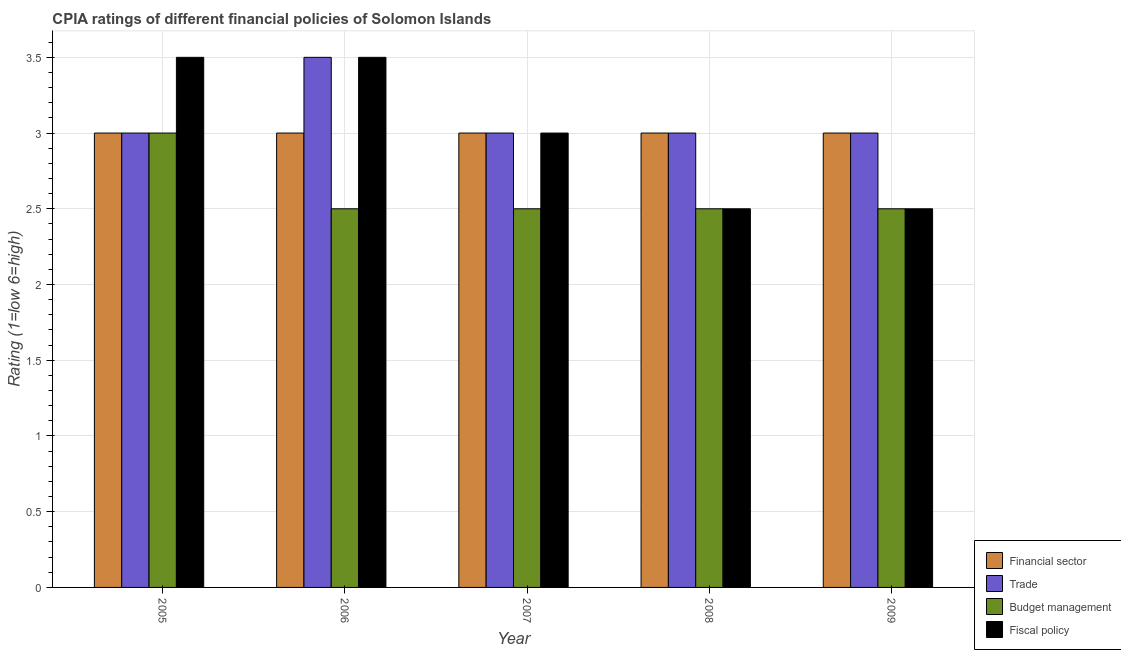How many different coloured bars are there?
Offer a very short reply. 4. Are the number of bars on each tick of the X-axis equal?
Make the answer very short. Yes. Across all years, what is the maximum cpia rating of fiscal policy?
Your response must be concise. 3.5. In which year was the cpia rating of financial sector maximum?
Your response must be concise. 2005. In which year was the cpia rating of financial sector minimum?
Your answer should be very brief. 2005. What is the difference between the cpia rating of trade in 2005 and the cpia rating of financial sector in 2009?
Provide a succinct answer. 0. What is the average cpia rating of budget management per year?
Your response must be concise. 2.6. What is the ratio of the cpia rating of budget management in 2005 to that in 2006?
Offer a very short reply. 1.2. What is the difference between the highest and the lowest cpia rating of trade?
Provide a short and direct response. 0.5. Is it the case that in every year, the sum of the cpia rating of fiscal policy and cpia rating of financial sector is greater than the sum of cpia rating of budget management and cpia rating of trade?
Ensure brevity in your answer.  No. What does the 1st bar from the left in 2007 represents?
Keep it short and to the point. Financial sector. What does the 4th bar from the right in 2008 represents?
Ensure brevity in your answer.  Financial sector. How many bars are there?
Your response must be concise. 20. What is the difference between two consecutive major ticks on the Y-axis?
Offer a very short reply. 0.5. Where does the legend appear in the graph?
Make the answer very short. Bottom right. What is the title of the graph?
Provide a short and direct response. CPIA ratings of different financial policies of Solomon Islands. Does "Norway" appear as one of the legend labels in the graph?
Your answer should be very brief. No. What is the label or title of the X-axis?
Ensure brevity in your answer.  Year. What is the Rating (1=low 6=high) in Trade in 2005?
Give a very brief answer. 3. What is the Rating (1=low 6=high) in Budget management in 2005?
Make the answer very short. 3. What is the Rating (1=low 6=high) in Fiscal policy in 2005?
Make the answer very short. 3.5. What is the Rating (1=low 6=high) in Trade in 2006?
Provide a short and direct response. 3.5. What is the Rating (1=low 6=high) of Financial sector in 2007?
Offer a very short reply. 3. What is the Rating (1=low 6=high) in Trade in 2007?
Your answer should be compact. 3. What is the Rating (1=low 6=high) in Budget management in 2007?
Provide a short and direct response. 2.5. What is the Rating (1=low 6=high) of Fiscal policy in 2007?
Keep it short and to the point. 3. What is the Rating (1=low 6=high) in Trade in 2008?
Make the answer very short. 3. What is the Rating (1=low 6=high) in Budget management in 2008?
Offer a terse response. 2.5. What is the Rating (1=low 6=high) of Financial sector in 2009?
Your response must be concise. 3. What is the Rating (1=low 6=high) of Trade in 2009?
Give a very brief answer. 3. What is the Rating (1=low 6=high) in Fiscal policy in 2009?
Keep it short and to the point. 2.5. Across all years, what is the minimum Rating (1=low 6=high) in Financial sector?
Give a very brief answer. 3. Across all years, what is the minimum Rating (1=low 6=high) of Trade?
Keep it short and to the point. 3. Across all years, what is the minimum Rating (1=low 6=high) of Fiscal policy?
Give a very brief answer. 2.5. What is the total Rating (1=low 6=high) of Financial sector in the graph?
Make the answer very short. 15. What is the total Rating (1=low 6=high) in Budget management in the graph?
Your answer should be compact. 13. What is the difference between the Rating (1=low 6=high) of Financial sector in 2005 and that in 2006?
Offer a terse response. 0. What is the difference between the Rating (1=low 6=high) of Budget management in 2005 and that in 2006?
Provide a short and direct response. 0.5. What is the difference between the Rating (1=low 6=high) in Fiscal policy in 2005 and that in 2006?
Ensure brevity in your answer.  0. What is the difference between the Rating (1=low 6=high) in Financial sector in 2005 and that in 2007?
Keep it short and to the point. 0. What is the difference between the Rating (1=low 6=high) in Fiscal policy in 2005 and that in 2007?
Your response must be concise. 0.5. What is the difference between the Rating (1=low 6=high) in Financial sector in 2005 and that in 2009?
Your response must be concise. 0. What is the difference between the Rating (1=low 6=high) in Budget management in 2005 and that in 2009?
Give a very brief answer. 0.5. What is the difference between the Rating (1=low 6=high) of Fiscal policy in 2005 and that in 2009?
Make the answer very short. 1. What is the difference between the Rating (1=low 6=high) of Financial sector in 2006 and that in 2007?
Your answer should be compact. 0. What is the difference between the Rating (1=low 6=high) of Trade in 2006 and that in 2007?
Ensure brevity in your answer.  0.5. What is the difference between the Rating (1=low 6=high) of Budget management in 2006 and that in 2007?
Make the answer very short. 0. What is the difference between the Rating (1=low 6=high) of Trade in 2006 and that in 2008?
Offer a terse response. 0.5. What is the difference between the Rating (1=low 6=high) of Budget management in 2006 and that in 2008?
Your answer should be very brief. 0. What is the difference between the Rating (1=low 6=high) of Fiscal policy in 2006 and that in 2008?
Provide a succinct answer. 1. What is the difference between the Rating (1=low 6=high) of Trade in 2006 and that in 2009?
Your answer should be very brief. 0.5. What is the difference between the Rating (1=low 6=high) of Budget management in 2006 and that in 2009?
Your answer should be compact. 0. What is the difference between the Rating (1=low 6=high) of Budget management in 2007 and that in 2008?
Make the answer very short. 0. What is the difference between the Rating (1=low 6=high) of Fiscal policy in 2007 and that in 2008?
Make the answer very short. 0.5. What is the difference between the Rating (1=low 6=high) in Financial sector in 2007 and that in 2009?
Make the answer very short. 0. What is the difference between the Rating (1=low 6=high) in Trade in 2007 and that in 2009?
Ensure brevity in your answer.  0. What is the difference between the Rating (1=low 6=high) of Budget management in 2007 and that in 2009?
Offer a very short reply. 0. What is the difference between the Rating (1=low 6=high) in Fiscal policy in 2007 and that in 2009?
Offer a terse response. 0.5. What is the difference between the Rating (1=low 6=high) of Financial sector in 2008 and that in 2009?
Offer a terse response. 0. What is the difference between the Rating (1=low 6=high) in Financial sector in 2005 and the Rating (1=low 6=high) in Trade in 2006?
Provide a short and direct response. -0.5. What is the difference between the Rating (1=low 6=high) in Financial sector in 2005 and the Rating (1=low 6=high) in Budget management in 2006?
Offer a terse response. 0.5. What is the difference between the Rating (1=low 6=high) in Budget management in 2005 and the Rating (1=low 6=high) in Fiscal policy in 2006?
Your response must be concise. -0.5. What is the difference between the Rating (1=low 6=high) in Financial sector in 2005 and the Rating (1=low 6=high) in Budget management in 2007?
Ensure brevity in your answer.  0.5. What is the difference between the Rating (1=low 6=high) of Financial sector in 2005 and the Rating (1=low 6=high) of Fiscal policy in 2007?
Give a very brief answer. 0. What is the difference between the Rating (1=low 6=high) of Trade in 2005 and the Rating (1=low 6=high) of Fiscal policy in 2007?
Keep it short and to the point. 0. What is the difference between the Rating (1=low 6=high) in Financial sector in 2005 and the Rating (1=low 6=high) in Trade in 2008?
Make the answer very short. 0. What is the difference between the Rating (1=low 6=high) of Financial sector in 2005 and the Rating (1=low 6=high) of Fiscal policy in 2008?
Your answer should be compact. 0.5. What is the difference between the Rating (1=low 6=high) of Trade in 2005 and the Rating (1=low 6=high) of Budget management in 2008?
Your answer should be compact. 0.5. What is the difference between the Rating (1=low 6=high) of Trade in 2005 and the Rating (1=low 6=high) of Fiscal policy in 2009?
Your answer should be very brief. 0.5. What is the difference between the Rating (1=low 6=high) in Budget management in 2005 and the Rating (1=low 6=high) in Fiscal policy in 2009?
Keep it short and to the point. 0.5. What is the difference between the Rating (1=low 6=high) of Financial sector in 2006 and the Rating (1=low 6=high) of Fiscal policy in 2007?
Provide a short and direct response. 0. What is the difference between the Rating (1=low 6=high) in Trade in 2006 and the Rating (1=low 6=high) in Budget management in 2007?
Make the answer very short. 1. What is the difference between the Rating (1=low 6=high) in Trade in 2006 and the Rating (1=low 6=high) in Fiscal policy in 2007?
Provide a short and direct response. 0.5. What is the difference between the Rating (1=low 6=high) in Financial sector in 2006 and the Rating (1=low 6=high) in Trade in 2008?
Provide a short and direct response. 0. What is the difference between the Rating (1=low 6=high) in Financial sector in 2006 and the Rating (1=low 6=high) in Budget management in 2008?
Offer a very short reply. 0.5. What is the difference between the Rating (1=low 6=high) in Budget management in 2006 and the Rating (1=low 6=high) in Fiscal policy in 2008?
Your response must be concise. 0. What is the difference between the Rating (1=low 6=high) in Financial sector in 2006 and the Rating (1=low 6=high) in Fiscal policy in 2009?
Ensure brevity in your answer.  0.5. What is the difference between the Rating (1=low 6=high) in Trade in 2006 and the Rating (1=low 6=high) in Budget management in 2009?
Keep it short and to the point. 1. What is the difference between the Rating (1=low 6=high) in Financial sector in 2007 and the Rating (1=low 6=high) in Budget management in 2008?
Your answer should be very brief. 0.5. What is the difference between the Rating (1=low 6=high) in Budget management in 2007 and the Rating (1=low 6=high) in Fiscal policy in 2008?
Your response must be concise. 0. What is the difference between the Rating (1=low 6=high) in Financial sector in 2007 and the Rating (1=low 6=high) in Trade in 2009?
Your answer should be compact. 0. What is the difference between the Rating (1=low 6=high) of Financial sector in 2007 and the Rating (1=low 6=high) of Budget management in 2009?
Your answer should be very brief. 0.5. What is the difference between the Rating (1=low 6=high) of Financial sector in 2007 and the Rating (1=low 6=high) of Fiscal policy in 2009?
Keep it short and to the point. 0.5. What is the difference between the Rating (1=low 6=high) in Trade in 2007 and the Rating (1=low 6=high) in Budget management in 2009?
Your response must be concise. 0.5. What is the difference between the Rating (1=low 6=high) in Trade in 2007 and the Rating (1=low 6=high) in Fiscal policy in 2009?
Offer a terse response. 0.5. What is the difference between the Rating (1=low 6=high) of Trade in 2008 and the Rating (1=low 6=high) of Budget management in 2009?
Offer a terse response. 0.5. What is the difference between the Rating (1=low 6=high) in Trade in 2008 and the Rating (1=low 6=high) in Fiscal policy in 2009?
Make the answer very short. 0.5. What is the difference between the Rating (1=low 6=high) in Budget management in 2008 and the Rating (1=low 6=high) in Fiscal policy in 2009?
Offer a terse response. 0. What is the average Rating (1=low 6=high) of Financial sector per year?
Provide a short and direct response. 3. In the year 2005, what is the difference between the Rating (1=low 6=high) of Financial sector and Rating (1=low 6=high) of Budget management?
Keep it short and to the point. 0. In the year 2005, what is the difference between the Rating (1=low 6=high) of Financial sector and Rating (1=low 6=high) of Fiscal policy?
Ensure brevity in your answer.  -0.5. In the year 2005, what is the difference between the Rating (1=low 6=high) in Trade and Rating (1=low 6=high) in Budget management?
Your answer should be compact. 0. In the year 2005, what is the difference between the Rating (1=low 6=high) in Trade and Rating (1=low 6=high) in Fiscal policy?
Provide a succinct answer. -0.5. In the year 2005, what is the difference between the Rating (1=low 6=high) of Budget management and Rating (1=low 6=high) of Fiscal policy?
Offer a very short reply. -0.5. In the year 2006, what is the difference between the Rating (1=low 6=high) of Financial sector and Rating (1=low 6=high) of Trade?
Your response must be concise. -0.5. In the year 2006, what is the difference between the Rating (1=low 6=high) in Financial sector and Rating (1=low 6=high) in Budget management?
Provide a succinct answer. 0.5. In the year 2006, what is the difference between the Rating (1=low 6=high) of Financial sector and Rating (1=low 6=high) of Fiscal policy?
Your response must be concise. -0.5. In the year 2007, what is the difference between the Rating (1=low 6=high) in Financial sector and Rating (1=low 6=high) in Trade?
Your answer should be compact. 0. In the year 2007, what is the difference between the Rating (1=low 6=high) in Financial sector and Rating (1=low 6=high) in Budget management?
Provide a short and direct response. 0.5. In the year 2007, what is the difference between the Rating (1=low 6=high) in Trade and Rating (1=low 6=high) in Budget management?
Your answer should be compact. 0.5. In the year 2007, what is the difference between the Rating (1=low 6=high) in Trade and Rating (1=low 6=high) in Fiscal policy?
Offer a terse response. 0. In the year 2007, what is the difference between the Rating (1=low 6=high) in Budget management and Rating (1=low 6=high) in Fiscal policy?
Your response must be concise. -0.5. In the year 2008, what is the difference between the Rating (1=low 6=high) in Trade and Rating (1=low 6=high) in Fiscal policy?
Provide a short and direct response. 0.5. In the year 2009, what is the difference between the Rating (1=low 6=high) in Financial sector and Rating (1=low 6=high) in Trade?
Ensure brevity in your answer.  0. In the year 2009, what is the difference between the Rating (1=low 6=high) in Financial sector and Rating (1=low 6=high) in Fiscal policy?
Give a very brief answer. 0.5. What is the ratio of the Rating (1=low 6=high) in Financial sector in 2005 to that in 2006?
Your answer should be very brief. 1. What is the ratio of the Rating (1=low 6=high) in Financial sector in 2005 to that in 2007?
Offer a terse response. 1. What is the ratio of the Rating (1=low 6=high) of Budget management in 2005 to that in 2007?
Offer a very short reply. 1.2. What is the ratio of the Rating (1=low 6=high) of Fiscal policy in 2005 to that in 2007?
Offer a very short reply. 1.17. What is the ratio of the Rating (1=low 6=high) of Budget management in 2005 to that in 2008?
Your answer should be very brief. 1.2. What is the ratio of the Rating (1=low 6=high) of Fiscal policy in 2005 to that in 2008?
Offer a very short reply. 1.4. What is the ratio of the Rating (1=low 6=high) of Trade in 2005 to that in 2009?
Your answer should be compact. 1. What is the ratio of the Rating (1=low 6=high) of Fiscal policy in 2005 to that in 2009?
Provide a succinct answer. 1.4. What is the ratio of the Rating (1=low 6=high) in Financial sector in 2006 to that in 2007?
Your response must be concise. 1. What is the ratio of the Rating (1=low 6=high) of Trade in 2006 to that in 2007?
Make the answer very short. 1.17. What is the ratio of the Rating (1=low 6=high) in Fiscal policy in 2006 to that in 2007?
Your response must be concise. 1.17. What is the ratio of the Rating (1=low 6=high) of Financial sector in 2006 to that in 2008?
Offer a terse response. 1. What is the ratio of the Rating (1=low 6=high) in Trade in 2006 to that in 2008?
Provide a short and direct response. 1.17. What is the ratio of the Rating (1=low 6=high) in Budget management in 2006 to that in 2008?
Provide a succinct answer. 1. What is the ratio of the Rating (1=low 6=high) of Financial sector in 2007 to that in 2008?
Keep it short and to the point. 1. What is the ratio of the Rating (1=low 6=high) in Budget management in 2007 to that in 2008?
Offer a very short reply. 1. What is the ratio of the Rating (1=low 6=high) in Financial sector in 2008 to that in 2009?
Your answer should be very brief. 1. What is the ratio of the Rating (1=low 6=high) of Budget management in 2008 to that in 2009?
Your answer should be compact. 1. What is the difference between the highest and the second highest Rating (1=low 6=high) of Financial sector?
Provide a short and direct response. 0. What is the difference between the highest and the lowest Rating (1=low 6=high) in Budget management?
Your answer should be very brief. 0.5. 